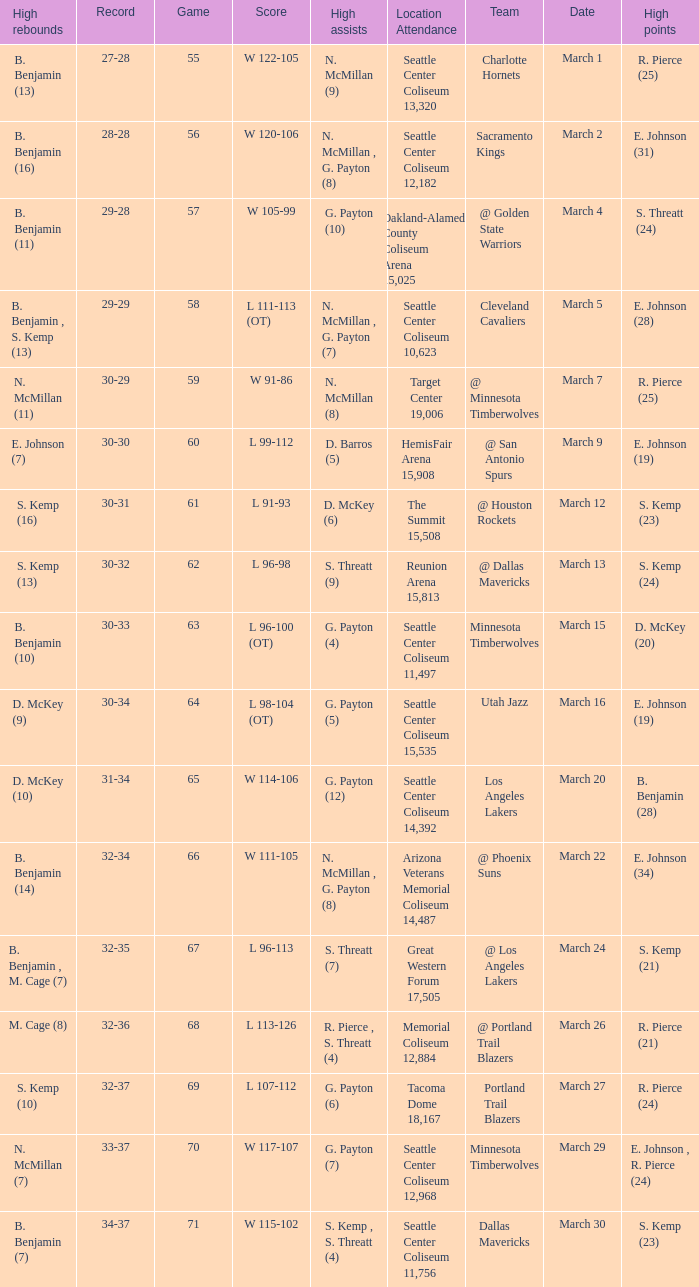Which game was played on march 2? 56.0. 